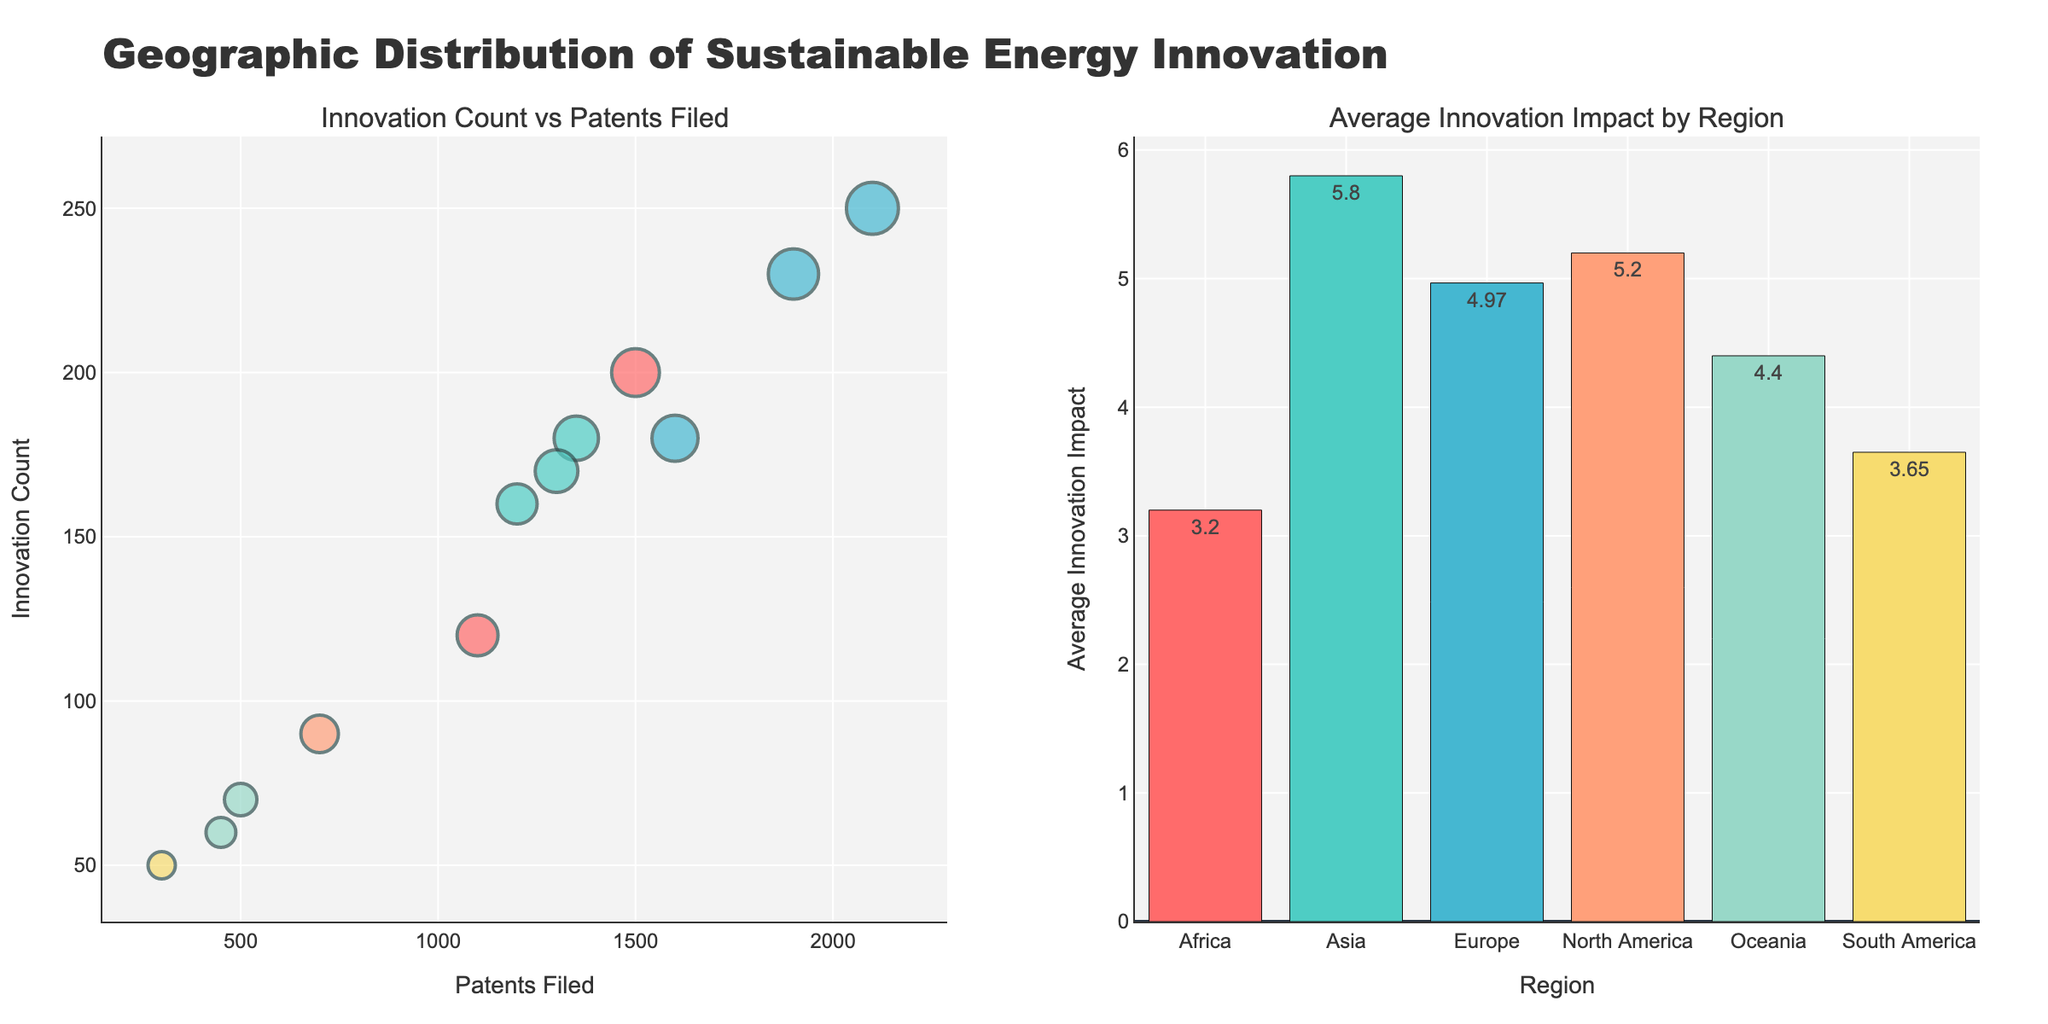How many regions are represented in the figure? Count the number of unique regions shown on the x-axis of the bar chart.
Answer: 6 Which country in North America has the highest Innovation Count? Compare the Innovation Count values of countries in North America: United States (200) and Canada (120). United States has the higher count.
Answer: United States What is the average Innovation Impact for Europe? Sum the Average Innovation Impact values for Germany (5.2), United Kingdom (4.7), and France (5.0) and divide by the number of countries (3): (5.2 + 4.7 + 5.0) / 3.
Answer: 4.97 Which region has the smallest bubble in the Innovation Count vs Patents Filed subplot? Identify the bubble with the smallest size in the scatter plot, which corresponds to South Africa with an Average Innovation Impact of 3.2.
Answer: Africa Which region filed the most patents? Locate the region with the highest value on the x-axis of the scatter plot. Asia, specifically China, has the highest Patents Filed value at 2100.
Answer: Asia How does the Average Innovation Impact of Oceania compare to that of South America? Compare the Average Innovation Impact values from the bar chart: Oceania (4.4) is greater than South America (3.65, averaging Brazil and Argentina).
Answer: Oceania is higher What is the total number of patents filed by countries in Europe? Sum the Patents Filed values for Germany (1350), United Kingdom (1200), and France (1300): 1350 + 1200 + 1300.
Answer: 3850 In the Innovation Count vs Patents Filed subplot, which country is represented by the largest bubble? Identify the largest bubble in terms of size and hover to find the country. This would be China with an Average Innovation Impact of 6.1.
Answer: China Which country in Asia has the lowest Average Innovation Impact? Compare the Average Innovation Impact values of countries in Asia: China (6.1), Japan (5.9), and South Korea (5.4). South Korea has the lowest impact.
Answer: South Korea 